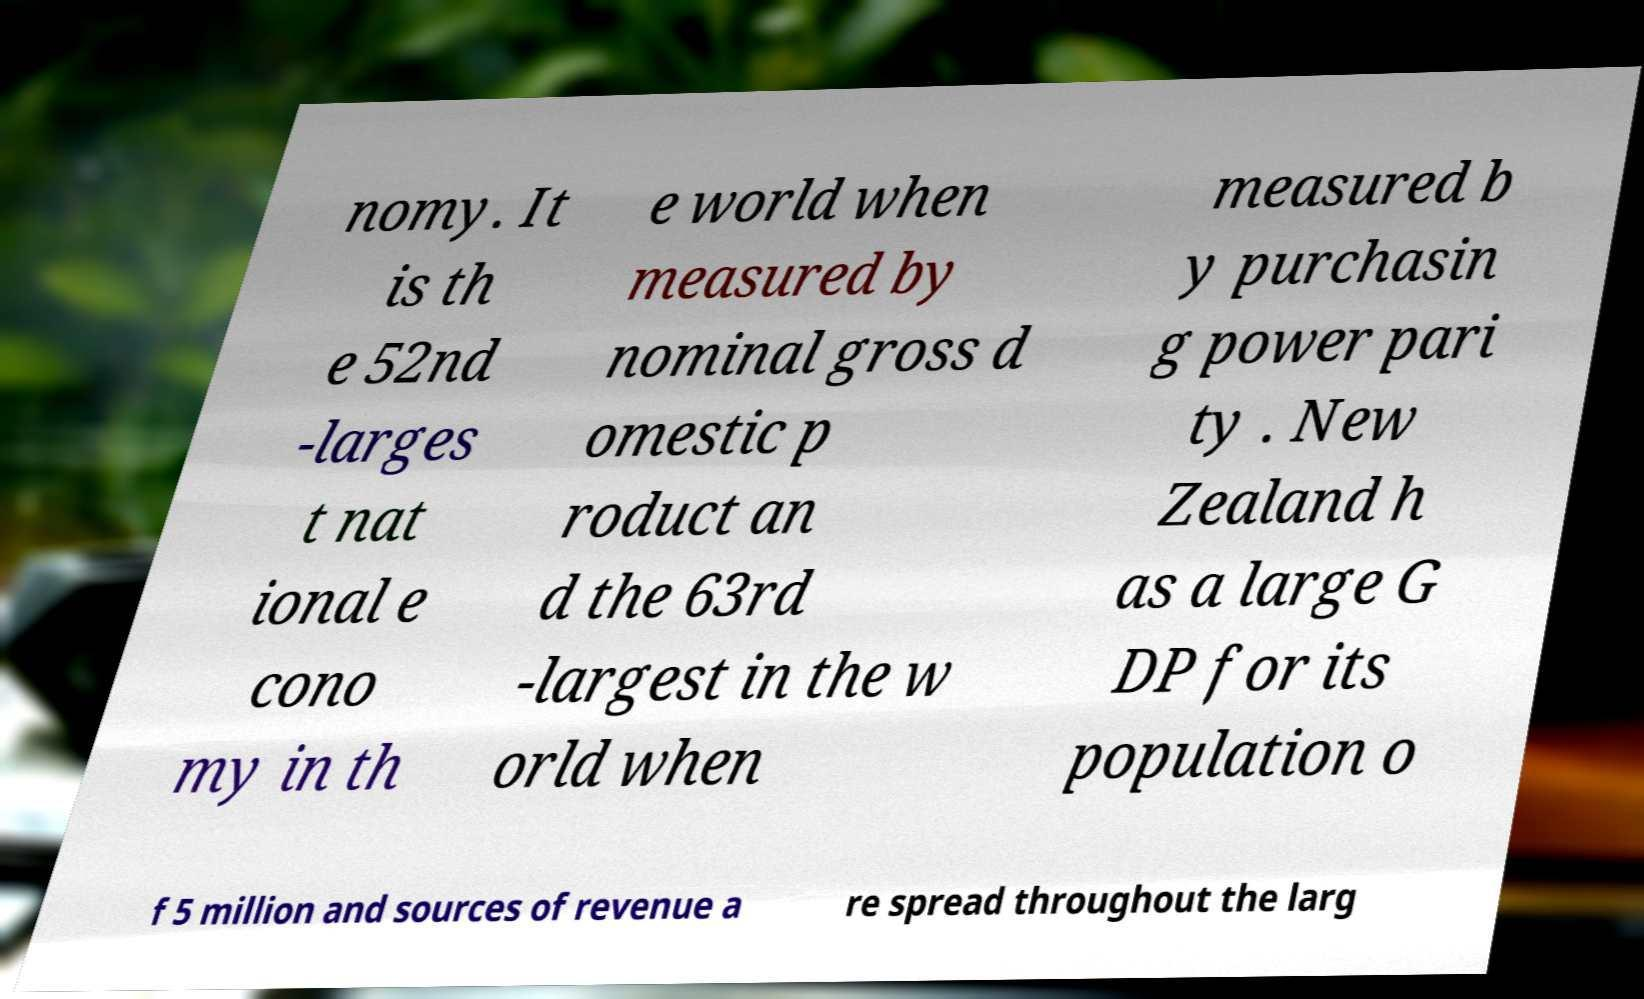Can you accurately transcribe the text from the provided image for me? nomy. It is th e 52nd -larges t nat ional e cono my in th e world when measured by nominal gross d omestic p roduct an d the 63rd -largest in the w orld when measured b y purchasin g power pari ty . New Zealand h as a large G DP for its population o f 5 million and sources of revenue a re spread throughout the larg 